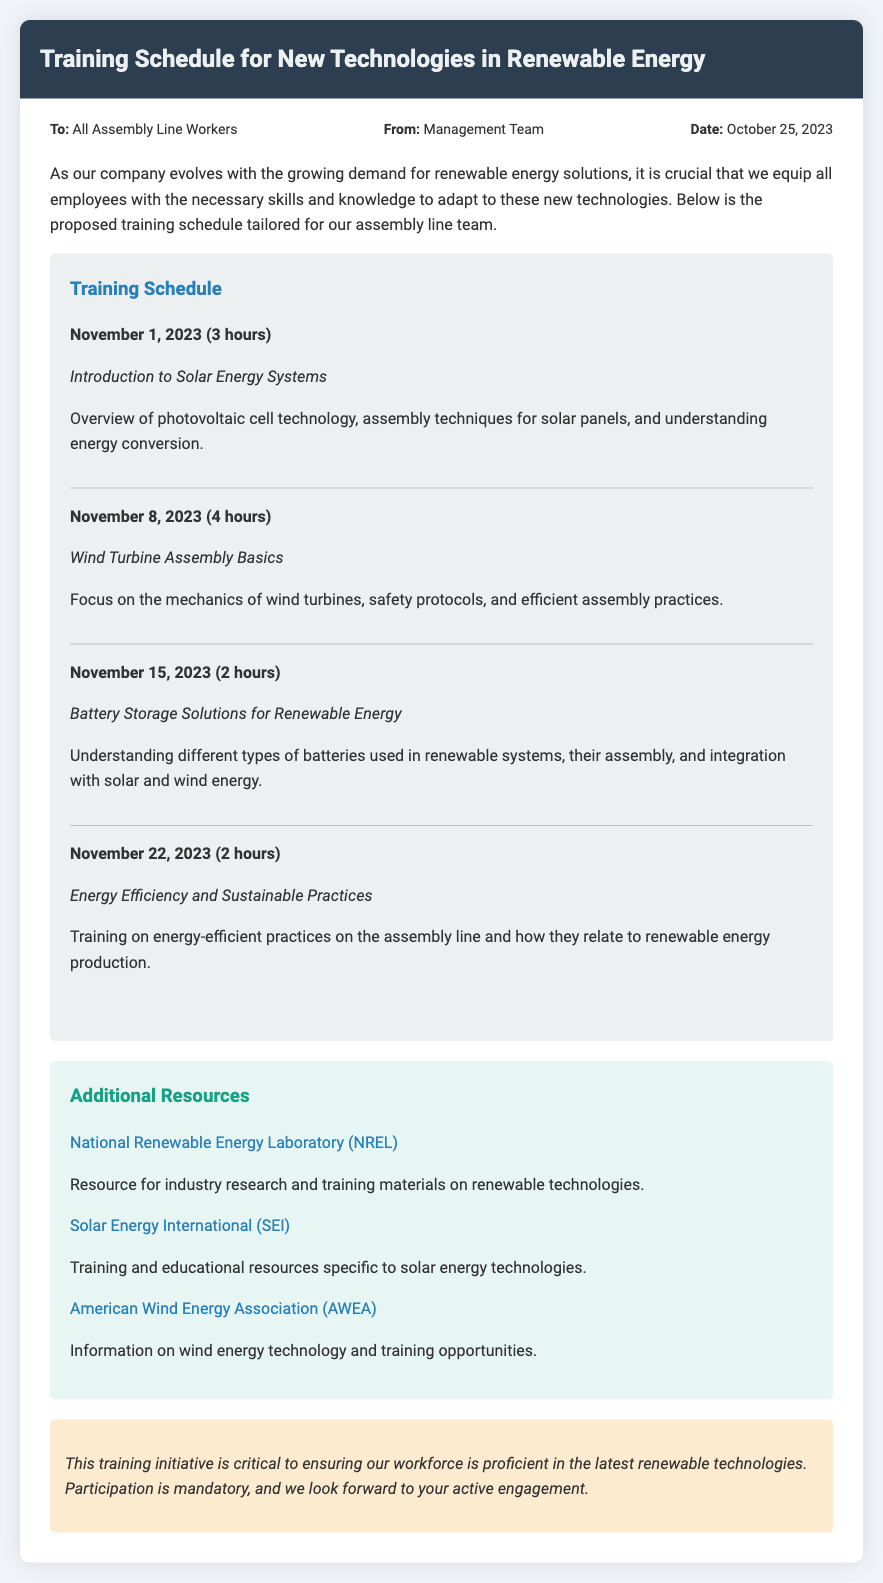What is the date of the memo? The date mentioned in the memo is provided in the meta section.
Answer: October 25, 2023 Who is the memo addressed to? The 'To' section states the recipient of the memo clearly.
Answer: All Assembly Line Workers How long is the training on November 8, 2023? The duration of that training session is specified in the schedule section.
Answer: 4 hours What is the focus of the training on November 15, 2023? The content and topic of each training session are provided in the schedule.
Answer: Battery Storage Solutions for Renewable Energy What are the additional resources mentioned in the document? The resources that provide further information are listed in the additional resources section.
Answer: National Renewable Energy Laboratory, Solar Energy International, American Wind Energy Association What is required from participants in this training initiative? The conclusion mentions the expectations set for the workforce regarding participation.
Answer: Participation is mandatory What is the main goal of the training sessions? The motive for organizing these training sessions is described in the introduction paragraph.
Answer: Equip employees with necessary skills How many total training sessions are listed in the memo? By counting the individual training items, we find the number of sessions specified.
Answer: 4 sessions 